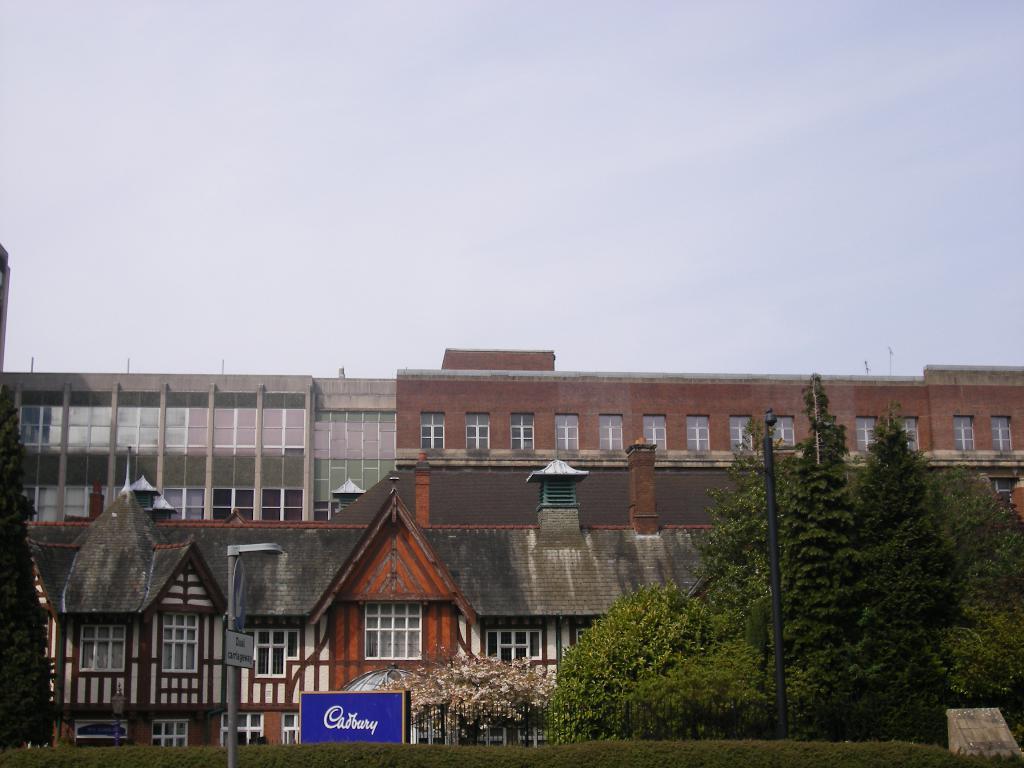Please provide a concise description of this image. In the image there are buildings in the back with trees in front of it on the right side and above its sky with clouds. 